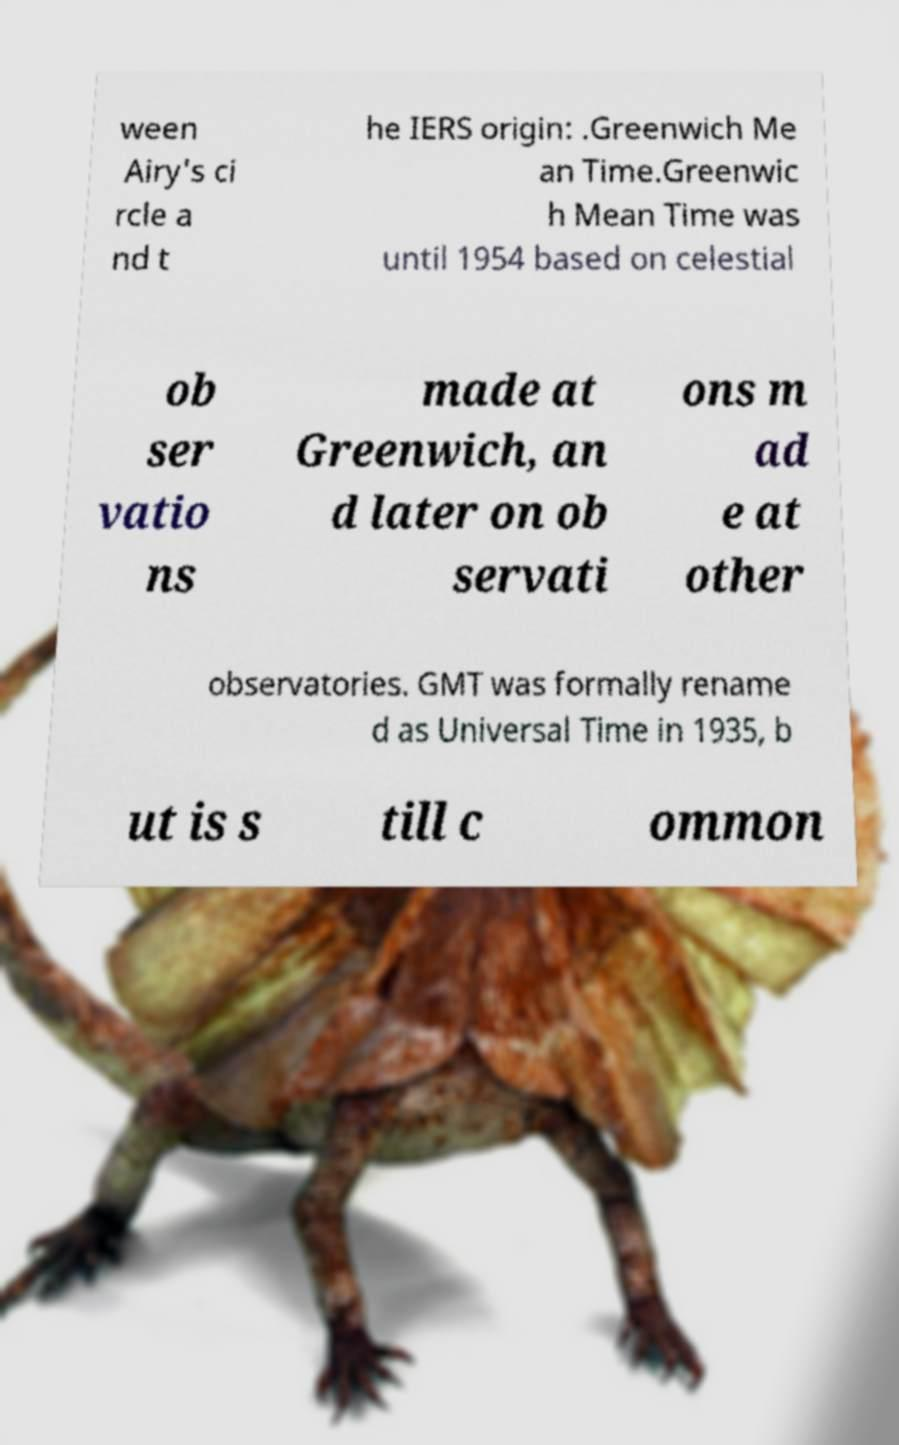Could you assist in decoding the text presented in this image and type it out clearly? ween Airy's ci rcle a nd t he IERS origin: .Greenwich Me an Time.Greenwic h Mean Time was until 1954 based on celestial ob ser vatio ns made at Greenwich, an d later on ob servati ons m ad e at other observatories. GMT was formally rename d as Universal Time in 1935, b ut is s till c ommon 